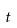<formula> <loc_0><loc_0><loc_500><loc_500>t</formula> 